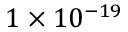Convert formula to latex. <formula><loc_0><loc_0><loc_500><loc_500>1 \times 1 0 ^ { - 1 9 }</formula> 